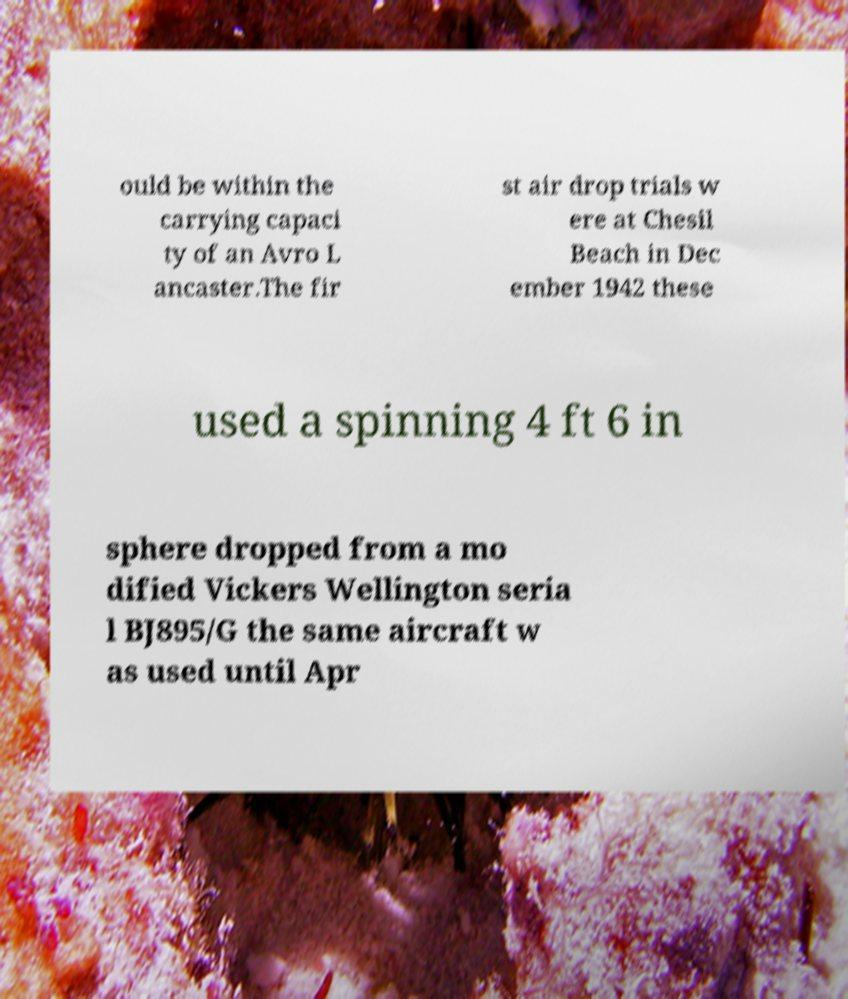I need the written content from this picture converted into text. Can you do that? ould be within the carrying capaci ty of an Avro L ancaster.The fir st air drop trials w ere at Chesil Beach in Dec ember 1942 these used a spinning 4 ft 6 in sphere dropped from a mo dified Vickers Wellington seria l BJ895/G the same aircraft w as used until Apr 